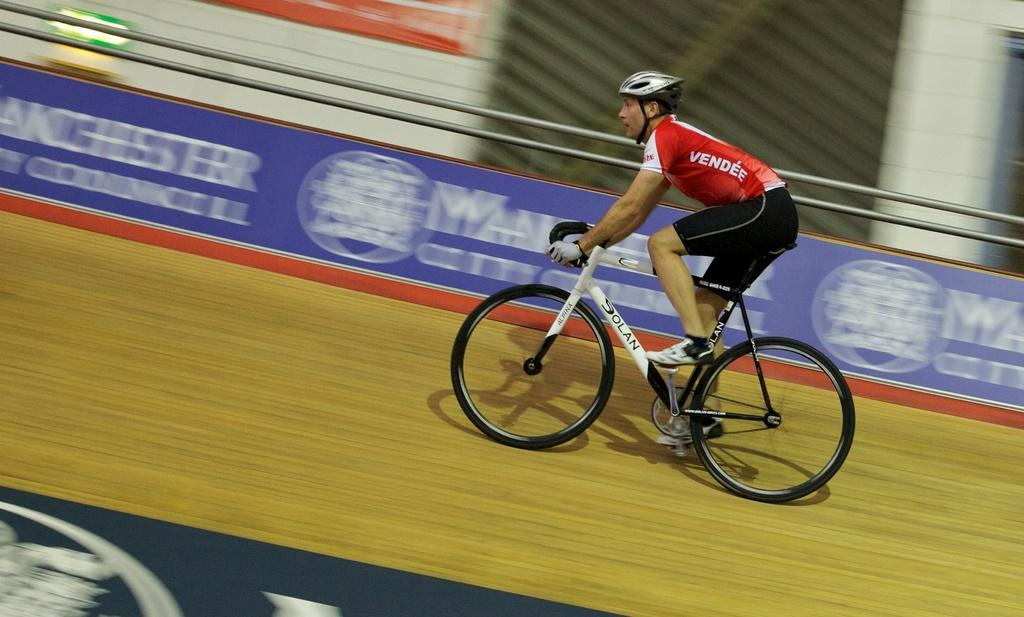What is the man in the image doing? The man in the image is riding a bicycle. What is the surface that the man is riding on? There is ground visible in the image, which the man is riding the bicycle on. What can be seen in the background of the image? There are banners and a railing in the background of the image. What type of wren can be seen perched on the railing in the image? There is no wren present in the image; it features a man riding a bicycle with banners and a railing in the background. 